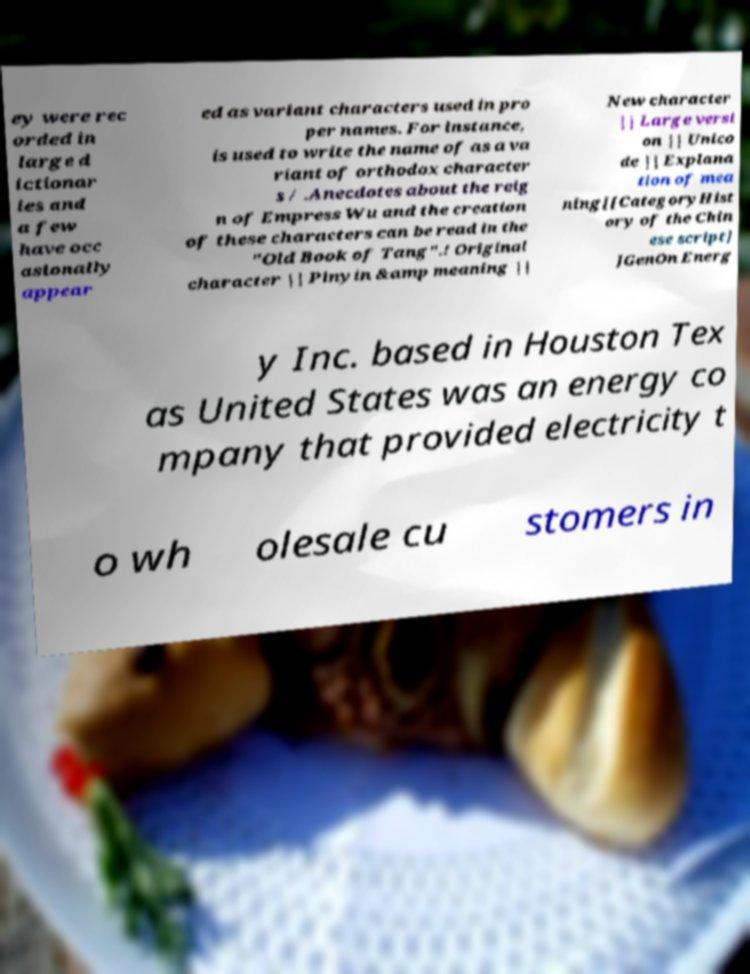Could you extract and type out the text from this image? ey were rec orded in large d ictionar ies and a few have occ asionally appear ed as variant characters used in pro per names. For instance, is used to write the name of as a va riant of orthodox character s / .Anecdotes about the reig n of Empress Wu and the creation of these characters can be read in the "Old Book of Tang".! Original character || Pinyin &amp meaning || New character || Large versi on || Unico de || Explana tion of mea ning[[CategoryHist ory of the Chin ese script] ]GenOn Energ y Inc. based in Houston Tex as United States was an energy co mpany that provided electricity t o wh olesale cu stomers in 